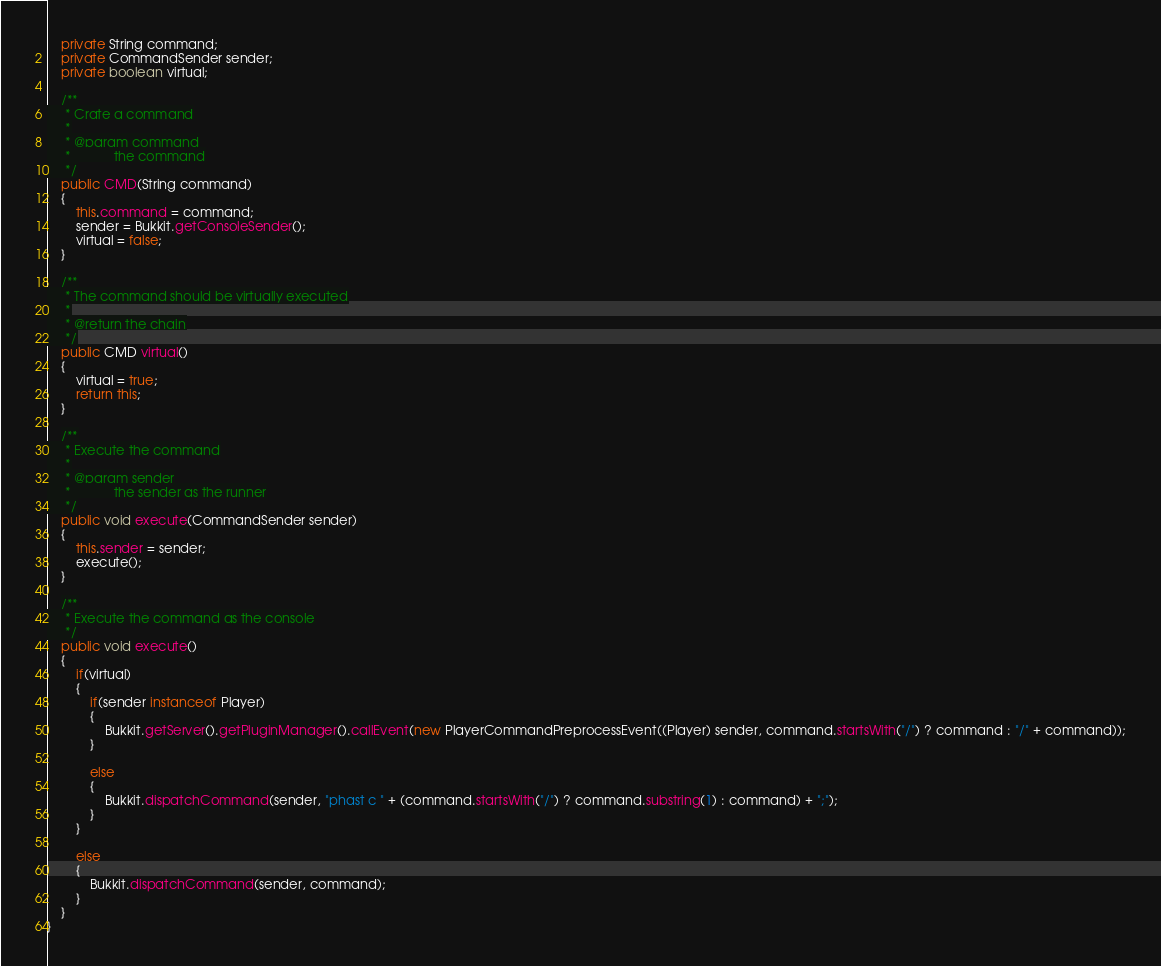Convert code to text. <code><loc_0><loc_0><loc_500><loc_500><_Java_>	private String command;
	private CommandSender sender;
	private boolean virtual;

	/**
	 * Crate a command
	 *
	 * @param command
	 *            the command
	 */
	public CMD(String command)
	{
		this.command = command;
		sender = Bukkit.getConsoleSender();
		virtual = false;
	}

	/**
	 * The command should be virtually executed
	 *
	 * @return the chain
	 */
	public CMD virtual()
	{
		virtual = true;
		return this;
	}

	/**
	 * Execute the command
	 *
	 * @param sender
	 *            the sender as the runner
	 */
	public void execute(CommandSender sender)
	{
		this.sender = sender;
		execute();
	}

	/**
	 * Execute the command as the console
	 */
	public void execute()
	{
		if(virtual)
		{
			if(sender instanceof Player)
			{
				Bukkit.getServer().getPluginManager().callEvent(new PlayerCommandPreprocessEvent((Player) sender, command.startsWith("/") ? command : "/" + command));
			}

			else
			{
				Bukkit.dispatchCommand(sender, "phast c " + (command.startsWith("/") ? command.substring(1) : command) + ";");
			}
		}

		else
		{
			Bukkit.dispatchCommand(sender, command);
		}
	}
}
</code> 